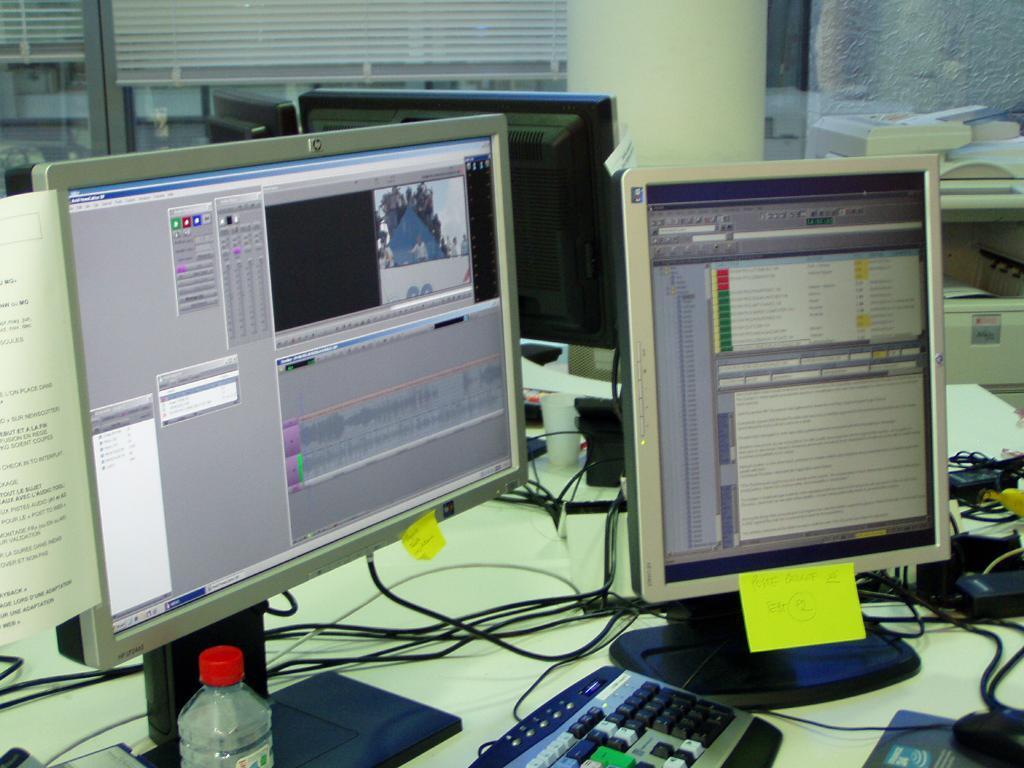Describe this image in one or two sentences. In this,there are four monitors. Two in the front and two in the back. One in the front is horizontal with a quick notes attached to it. There is a keyboard and mouse in front of it. The monitor beside it is in a vertical position with a yellow note pasted. There is water bottle in front of them. 